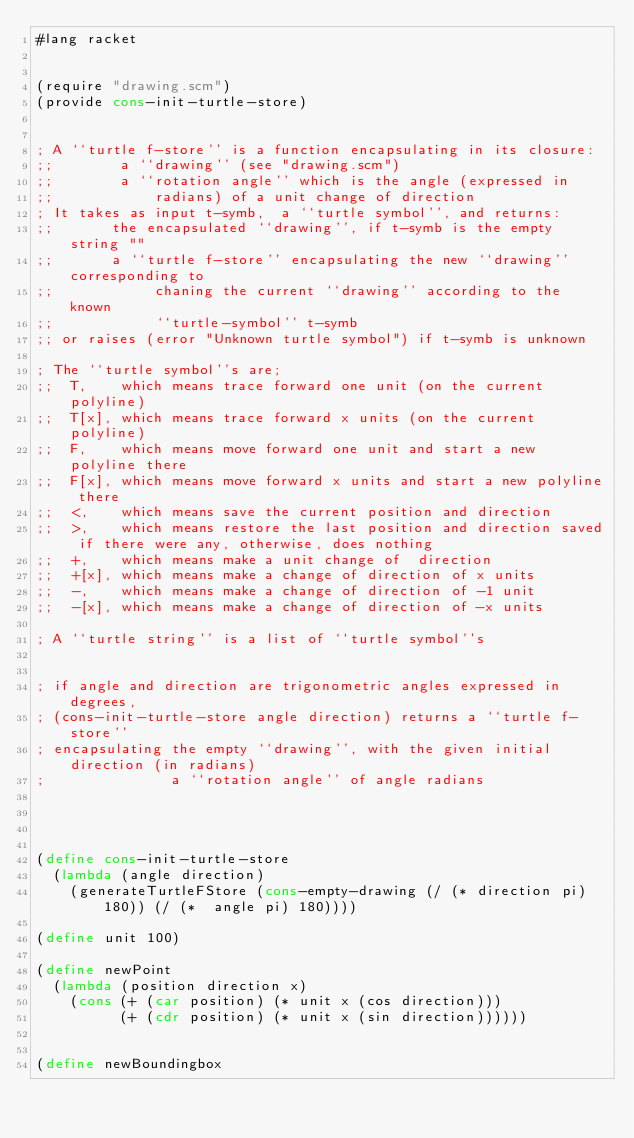<code> <loc_0><loc_0><loc_500><loc_500><_Scheme_>#lang racket


(require "drawing.scm")
(provide cons-init-turtle-store)


; A ``turtle f-store'' is a function encapsulating in its closure:
;;        a ``drawing'' (see "drawing.scm")
;;        a ``rotation angle'' which is the angle (expressed in
;;            radians) of a unit change of direction
; It takes as input t-symb,  a ``turtle symbol'', and returns:
;;       the encapsulated ``drawing'', if t-symb is the empty string ""
;;       a ``turtle f-store'' encapsulating the new ``drawing'' corresponding to
;;            chaning the current ``drawing'' according to the known
;;            ``turtle-symbol'' t-symb
;; or raises (error "Unknown turtle symbol") if t-symb is unknown

; The ``turtle symbol''s are;
;;  T,    which means trace forward one unit (on the current polyline)
;;  T[x], which means trace forward x units (on the current polyline)
;;  F,    which means move forward one unit and start a new polyline there
;;  F[x], which means move forward x units and start a new polyline there
;;  <,    which means save the current position and direction
;;  >,    which means restore the last position and direction saved if there were any, otherwise, does nothing
;;  +,    which means make a unit change of  direction
;;  +[x], which means make a change of direction of x units
;;  -,    which means make a change of direction of -1 unit
;;  -[x], which means make a change of direction of -x units

; A ``turtle string'' is a list of ``turtle symbol''s


; if angle and direction are trigonometric angles expressed in degrees,
; (cons-init-turtle-store angle direction) returns a ``turtle f-store''
; encapsulating the empty ``drawing'', with the given initial direction (in radians)
;               a ``rotation angle'' of angle radians




(define cons-init-turtle-store
  (lambda (angle direction)
    (generateTurtleFStore (cons-empty-drawing (/ (* direction pi) 180)) (/ (*  angle pi) 180))))

(define unit 100)

(define newPoint
  (lambda (position direction x)
    (cons (+ (car position) (* unit x (cos direction)))
          (+ (cdr position) (* unit x (sin direction))))))


(define newBoundingbox</code> 